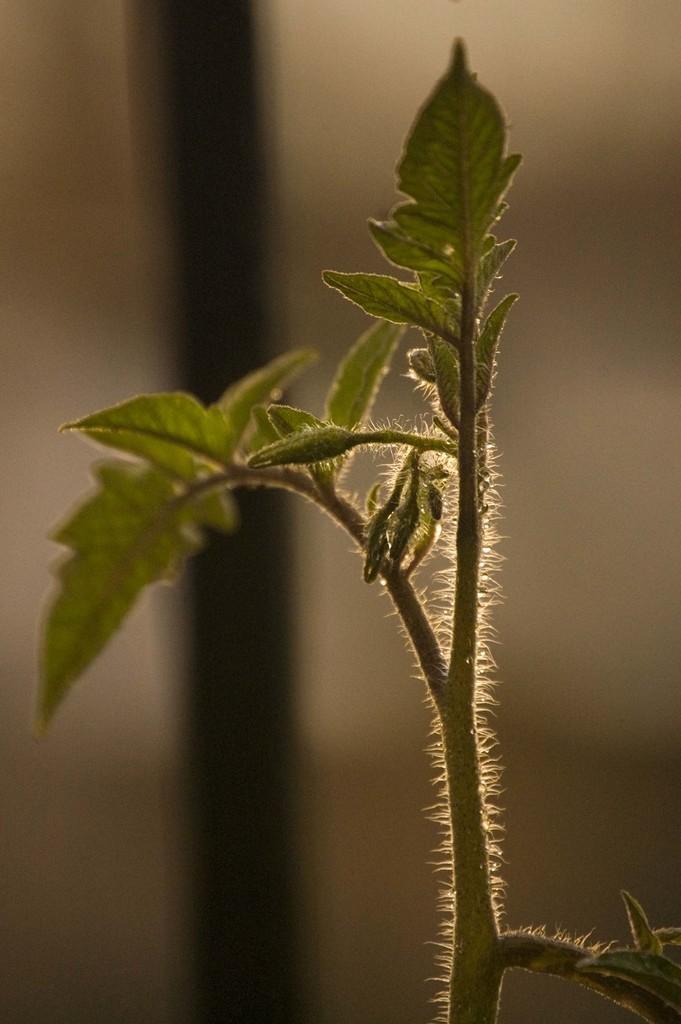Describe this image in one or two sentences. In this image I can see a green color plant. Background is in brown and black color. 